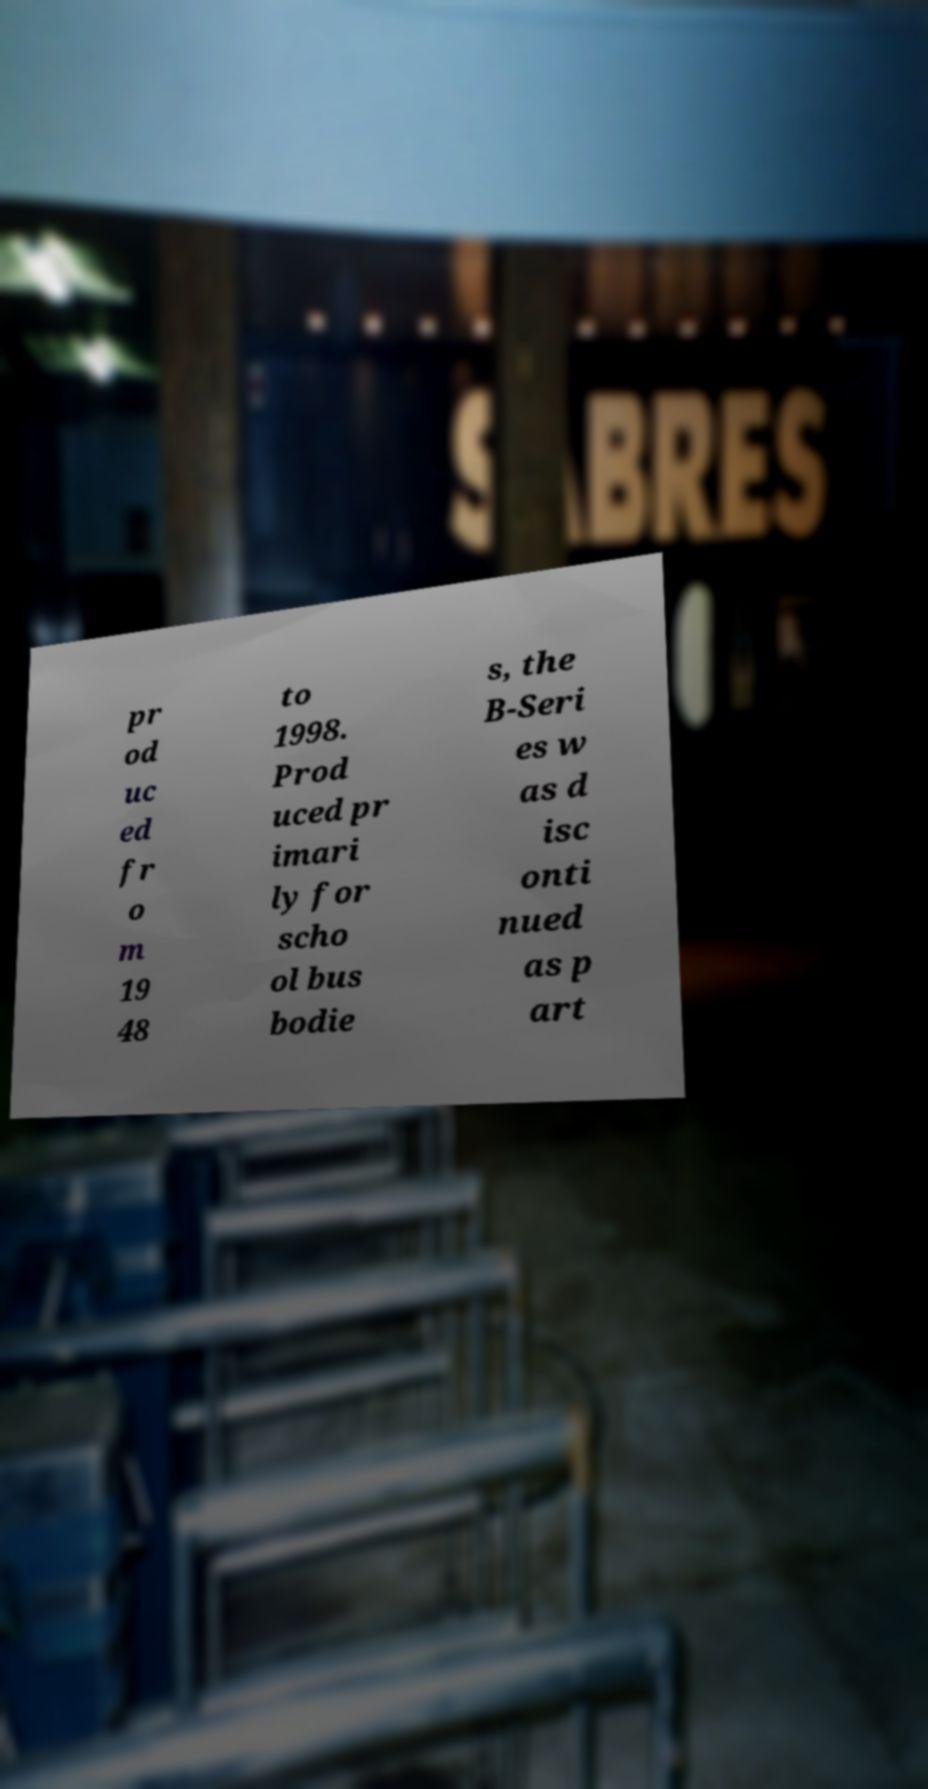Please read and relay the text visible in this image. What does it say? pr od uc ed fr o m 19 48 to 1998. Prod uced pr imari ly for scho ol bus bodie s, the B-Seri es w as d isc onti nued as p art 